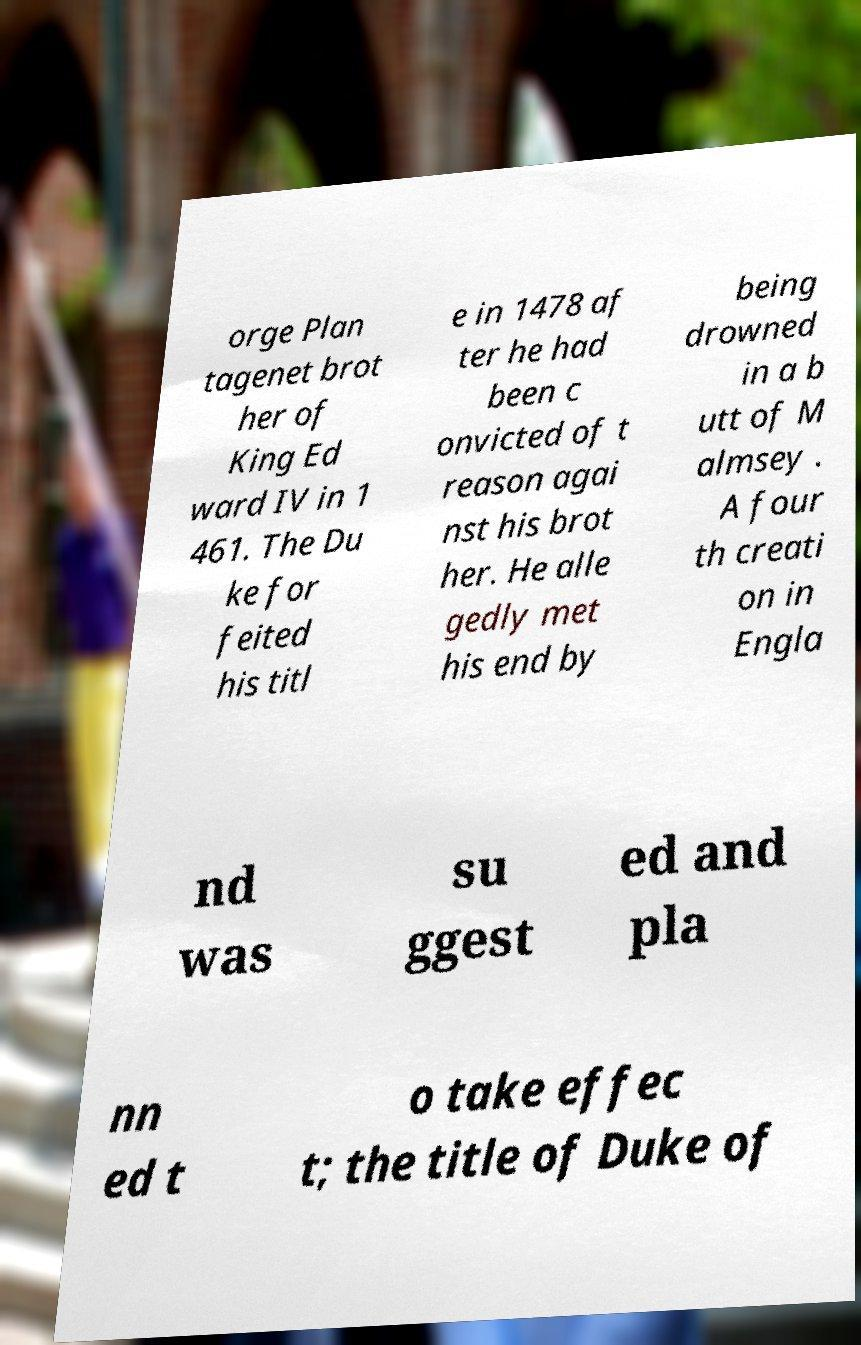Can you accurately transcribe the text from the provided image for me? orge Plan tagenet brot her of King Ed ward IV in 1 461. The Du ke for feited his titl e in 1478 af ter he had been c onvicted of t reason agai nst his brot her. He alle gedly met his end by being drowned in a b utt of M almsey . A four th creati on in Engla nd was su ggest ed and pla nn ed t o take effec t; the title of Duke of 